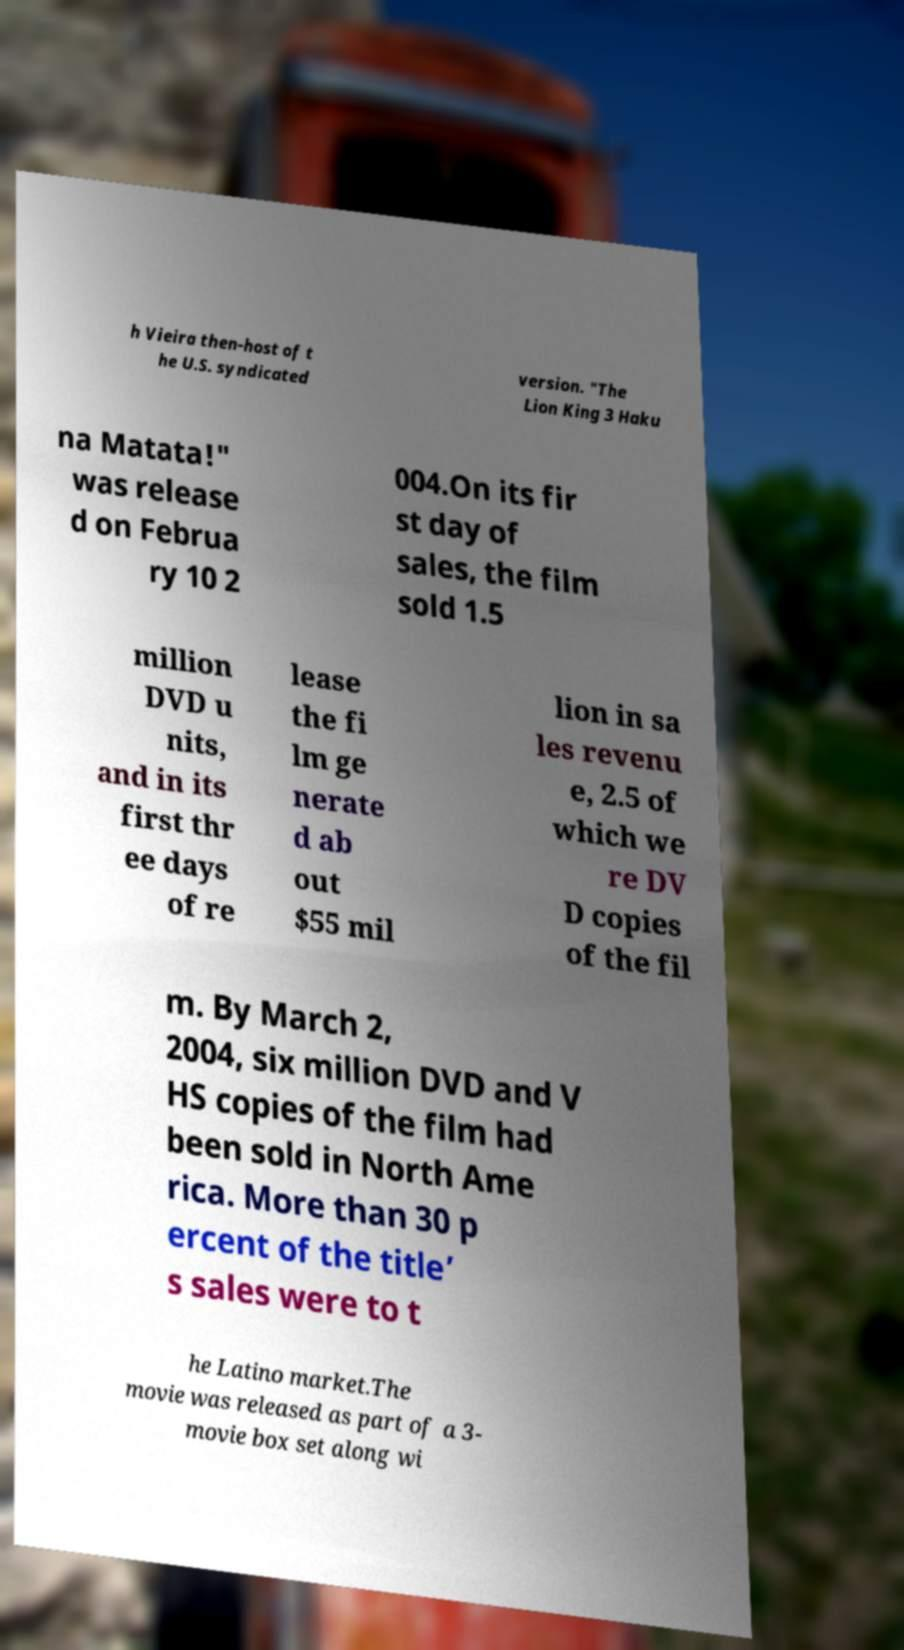Can you read and provide the text displayed in the image?This photo seems to have some interesting text. Can you extract and type it out for me? h Vieira then-host of t he U.S. syndicated version. "The Lion King 3 Haku na Matata!" was release d on Februa ry 10 2 004.On its fir st day of sales, the film sold 1.5 million DVD u nits, and in its first thr ee days of re lease the fi lm ge nerate d ab out $55 mil lion in sa les revenu e, 2.5 of which we re DV D copies of the fil m. By March 2, 2004, six million DVD and V HS copies of the film had been sold in North Ame rica. More than 30 p ercent of the title’ s sales were to t he Latino market.The movie was released as part of a 3- movie box set along wi 